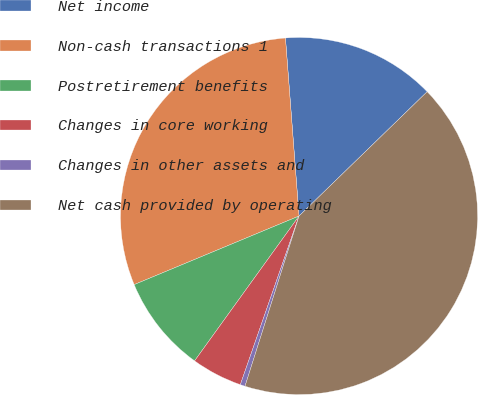Convert chart. <chart><loc_0><loc_0><loc_500><loc_500><pie_chart><fcel>Net income<fcel>Non-cash transactions 1<fcel>Postretirement benefits<fcel>Changes in core working<fcel>Changes in other assets and<fcel>Net cash provided by operating<nl><fcel>13.95%<fcel>30.06%<fcel>8.78%<fcel>4.61%<fcel>0.44%<fcel>42.15%<nl></chart> 